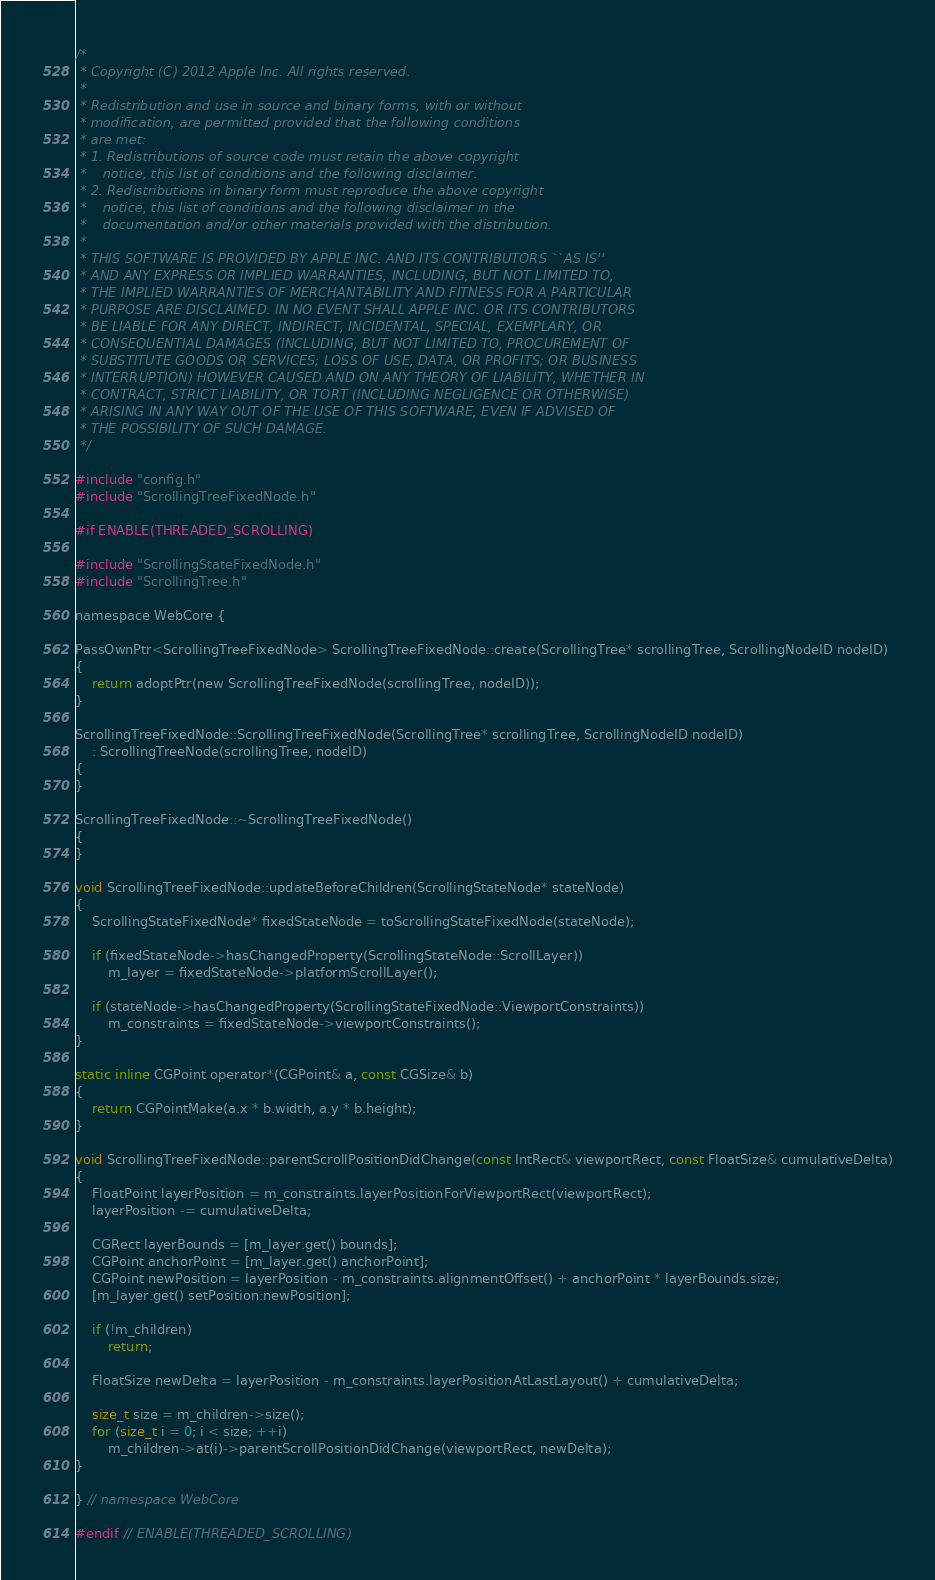Convert code to text. <code><loc_0><loc_0><loc_500><loc_500><_ObjectiveC_>/*
 * Copyright (C) 2012 Apple Inc. All rights reserved.
 *
 * Redistribution and use in source and binary forms, with or without
 * modification, are permitted provided that the following conditions
 * are met:
 * 1. Redistributions of source code must retain the above copyright
 *    notice, this list of conditions and the following disclaimer.
 * 2. Redistributions in binary form must reproduce the above copyright
 *    notice, this list of conditions and the following disclaimer in the
 *    documentation and/or other materials provided with the distribution.
 *
 * THIS SOFTWARE IS PROVIDED BY APPLE INC. AND ITS CONTRIBUTORS ``AS IS''
 * AND ANY EXPRESS OR IMPLIED WARRANTIES, INCLUDING, BUT NOT LIMITED TO,
 * THE IMPLIED WARRANTIES OF MERCHANTABILITY AND FITNESS FOR A PARTICULAR
 * PURPOSE ARE DISCLAIMED. IN NO EVENT SHALL APPLE INC. OR ITS CONTRIBUTORS
 * BE LIABLE FOR ANY DIRECT, INDIRECT, INCIDENTAL, SPECIAL, EXEMPLARY, OR
 * CONSEQUENTIAL DAMAGES (INCLUDING, BUT NOT LIMITED TO, PROCUREMENT OF
 * SUBSTITUTE GOODS OR SERVICES; LOSS OF USE, DATA, OR PROFITS; OR BUSINESS
 * INTERRUPTION) HOWEVER CAUSED AND ON ANY THEORY OF LIABILITY, WHETHER IN
 * CONTRACT, STRICT LIABILITY, OR TORT (INCLUDING NEGLIGENCE OR OTHERWISE)
 * ARISING IN ANY WAY OUT OF THE USE OF THIS SOFTWARE, EVEN IF ADVISED OF
 * THE POSSIBILITY OF SUCH DAMAGE.
 */

#include "config.h"
#include "ScrollingTreeFixedNode.h"

#if ENABLE(THREADED_SCROLLING)

#include "ScrollingStateFixedNode.h"
#include "ScrollingTree.h"

namespace WebCore {

PassOwnPtr<ScrollingTreeFixedNode> ScrollingTreeFixedNode::create(ScrollingTree* scrollingTree, ScrollingNodeID nodeID)
{
    return adoptPtr(new ScrollingTreeFixedNode(scrollingTree, nodeID));
}

ScrollingTreeFixedNode::ScrollingTreeFixedNode(ScrollingTree* scrollingTree, ScrollingNodeID nodeID)
    : ScrollingTreeNode(scrollingTree, nodeID)
{
}

ScrollingTreeFixedNode::~ScrollingTreeFixedNode()
{
}

void ScrollingTreeFixedNode::updateBeforeChildren(ScrollingStateNode* stateNode)
{
    ScrollingStateFixedNode* fixedStateNode = toScrollingStateFixedNode(stateNode);

    if (fixedStateNode->hasChangedProperty(ScrollingStateNode::ScrollLayer))
        m_layer = fixedStateNode->platformScrollLayer();

    if (stateNode->hasChangedProperty(ScrollingStateFixedNode::ViewportConstraints))
        m_constraints = fixedStateNode->viewportConstraints();
}

static inline CGPoint operator*(CGPoint& a, const CGSize& b)
{
    return CGPointMake(a.x * b.width, a.y * b.height);
}

void ScrollingTreeFixedNode::parentScrollPositionDidChange(const IntRect& viewportRect, const FloatSize& cumulativeDelta)
{
    FloatPoint layerPosition = m_constraints.layerPositionForViewportRect(viewportRect);
    layerPosition -= cumulativeDelta;

    CGRect layerBounds = [m_layer.get() bounds];
    CGPoint anchorPoint = [m_layer.get() anchorPoint];
    CGPoint newPosition = layerPosition - m_constraints.alignmentOffset() + anchorPoint * layerBounds.size;
    [m_layer.get() setPosition:newPosition];

    if (!m_children)
        return;

    FloatSize newDelta = layerPosition - m_constraints.layerPositionAtLastLayout() + cumulativeDelta;

    size_t size = m_children->size();
    for (size_t i = 0; i < size; ++i)
        m_children->at(i)->parentScrollPositionDidChange(viewportRect, newDelta);
}

} // namespace WebCore

#endif // ENABLE(THREADED_SCROLLING)
</code> 